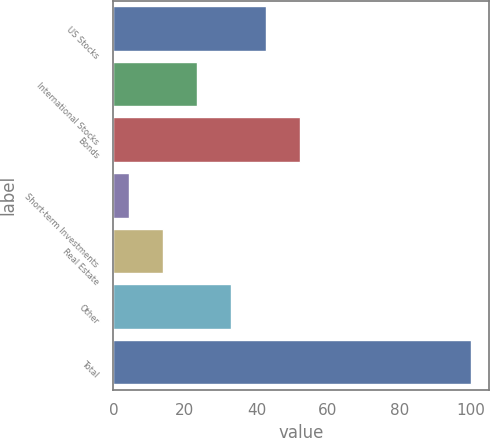Convert chart. <chart><loc_0><loc_0><loc_500><loc_500><bar_chart><fcel>US Stocks<fcel>International Stocks<fcel>Bonds<fcel>Short-term Investments<fcel>Real Estate<fcel>Other<fcel>Total<nl><fcel>42.58<fcel>23.44<fcel>52.15<fcel>4.3<fcel>13.87<fcel>33.01<fcel>100<nl></chart> 